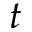<formula> <loc_0><loc_0><loc_500><loc_500>t</formula> 